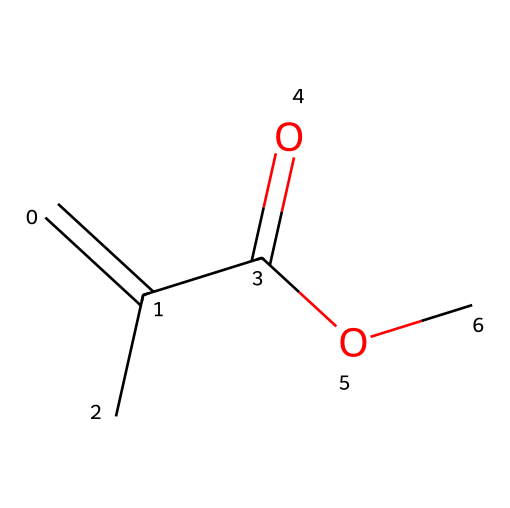What is the name of this chemical? The SMILES representation corresponds to methyl methacrylate, a common monomer used in acrylic glass production. Thus, recognizing the structure allows us to name it accurately.
Answer: methyl methacrylate How many carbon atoms are in the chemical structure? By analyzing the SMILES string, we can count the carbon atoms: there are 5 carbon atoms identified within the structure.
Answer: 5 What functional group is present in methyl methacrylate? The structure includes a methacrylate group which features a carbonyl (C=O) and an ester (C-O) group, indicating it is an ester functional group.
Answer: ester What is the degree of unsaturation in this molecule? The degree of unsaturation can be determined by analyzing the structure: there is one double bond (C=C) and one carbonyl (C=O), leading to a total of two degrees of unsaturation.
Answer: 2 Is methyl methacrylate a monomer or a polymer? Methyl methacrylate is specifically classified as a monomer, which is a single unit that can polymerize to form a polymer.
Answer: monomer How many hydrogen atoms are bonded in the structure? By assessing the SMILES, we find that there are 8 hydrogen atoms connected to the carbon atoms in the molecular structure.
Answer: 8 